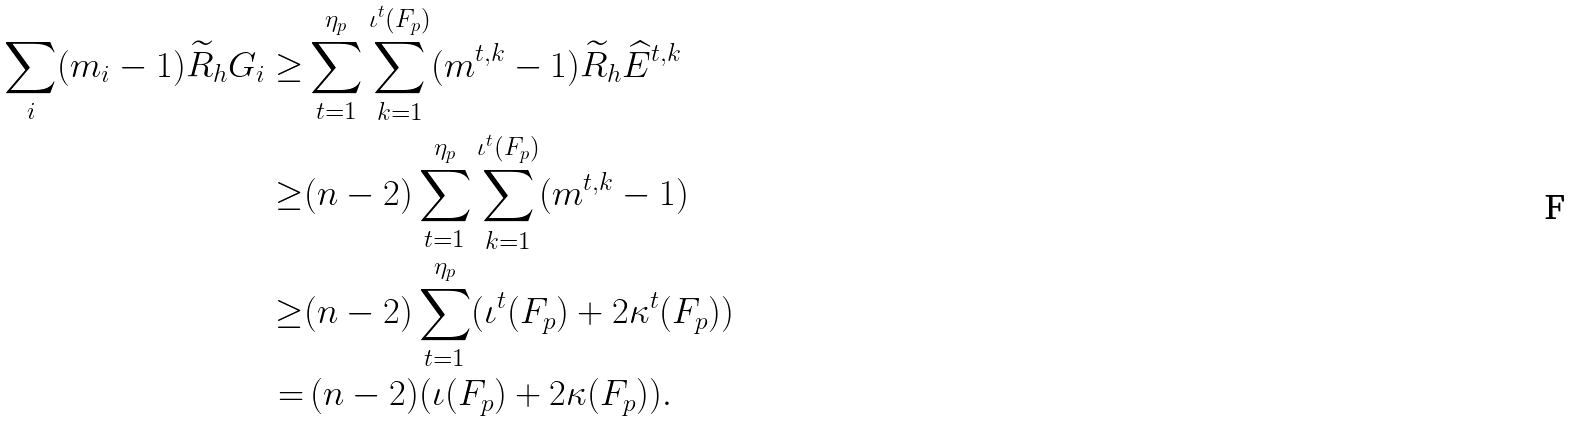Convert formula to latex. <formula><loc_0><loc_0><loc_500><loc_500>\sum _ { i } ( m _ { i } - 1 ) \widetilde { R } _ { h } G _ { i } \geq & \sum _ { t = 1 } ^ { \eta _ { p } } \sum _ { k = 1 } ^ { \iota ^ { t } ( F _ { p } ) } ( m ^ { t , k } - 1 ) \widetilde { R } _ { h } \widehat { E } ^ { t , k } \\ \geq & ( n - 2 ) \sum _ { t = 1 } ^ { \eta _ { p } } \sum _ { k = 1 } ^ { \iota ^ { t } ( F _ { p } ) } ( m ^ { t , k } - 1 ) \\ \geq & ( n - 2 ) \sum _ { t = 1 } ^ { \eta _ { p } } ( \iota ^ { t } ( F _ { p } ) + 2 \kappa ^ { t } ( F _ { p } ) ) \\ = & \, ( n - 2 ) ( \iota ( F _ { p } ) + 2 \kappa ( F _ { p } ) ) .</formula> 